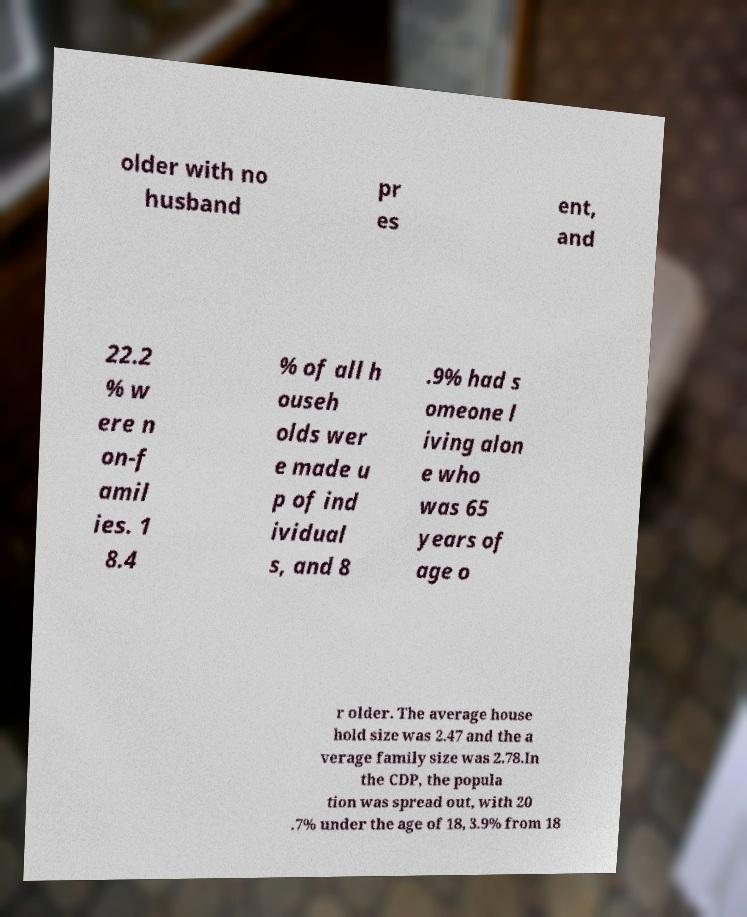Could you assist in decoding the text presented in this image and type it out clearly? older with no husband pr es ent, and 22.2 % w ere n on-f amil ies. 1 8.4 % of all h ouseh olds wer e made u p of ind ividual s, and 8 .9% had s omeone l iving alon e who was 65 years of age o r older. The average house hold size was 2.47 and the a verage family size was 2.78.In the CDP, the popula tion was spread out, with 20 .7% under the age of 18, 3.9% from 18 